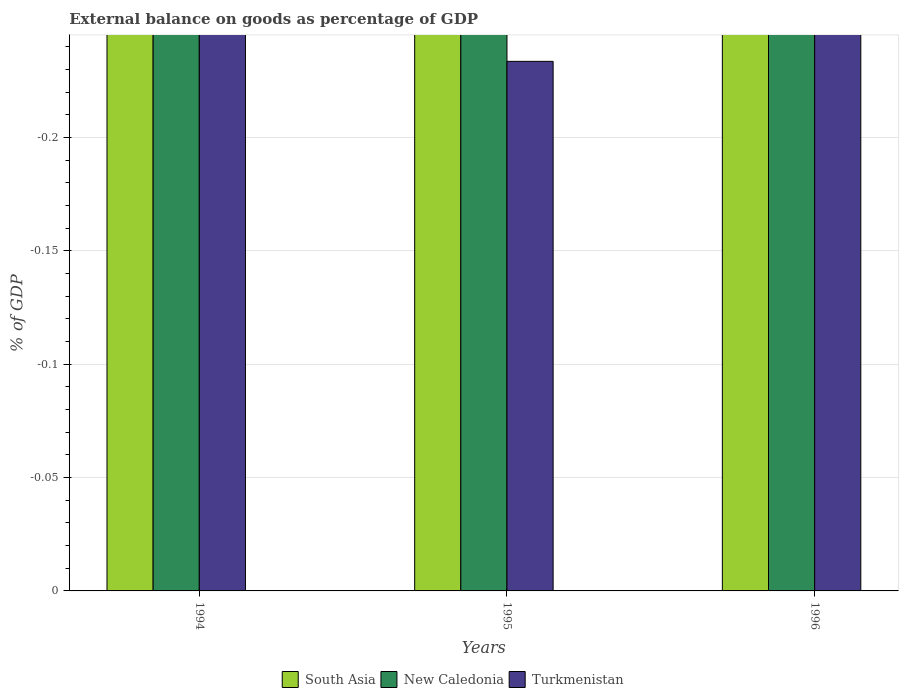How many different coloured bars are there?
Your answer should be compact. 0. Are the number of bars per tick equal to the number of legend labels?
Keep it short and to the point. No. In how many cases, is the number of bars for a given year not equal to the number of legend labels?
Keep it short and to the point. 3. What is the external balance on goods as percentage of GDP in South Asia in 1996?
Offer a terse response. 0. What is the average external balance on goods as percentage of GDP in Turkmenistan per year?
Your answer should be very brief. 0. In how many years, is the external balance on goods as percentage of GDP in South Asia greater than -0.010000000000000002 %?
Provide a succinct answer. 0. Is it the case that in every year, the sum of the external balance on goods as percentage of GDP in New Caledonia and external balance on goods as percentage of GDP in South Asia is greater than the external balance on goods as percentage of GDP in Turkmenistan?
Give a very brief answer. No. Are all the bars in the graph horizontal?
Ensure brevity in your answer.  No. What is the difference between two consecutive major ticks on the Y-axis?
Your answer should be very brief. 0.05. Where does the legend appear in the graph?
Provide a succinct answer. Bottom center. How many legend labels are there?
Your answer should be very brief. 3. How are the legend labels stacked?
Offer a terse response. Horizontal. What is the title of the graph?
Your answer should be compact. External balance on goods as percentage of GDP. What is the label or title of the Y-axis?
Offer a very short reply. % of GDP. What is the % of GDP of New Caledonia in 1994?
Provide a succinct answer. 0. What is the % of GDP of Turkmenistan in 1994?
Make the answer very short. 0. What is the % of GDP in South Asia in 1995?
Make the answer very short. 0. What is the % of GDP of New Caledonia in 1995?
Make the answer very short. 0. What is the % of GDP of South Asia in 1996?
Keep it short and to the point. 0. What is the % of GDP in New Caledonia in 1996?
Keep it short and to the point. 0. What is the % of GDP of Turkmenistan in 1996?
Your answer should be compact. 0. What is the total % of GDP of Turkmenistan in the graph?
Ensure brevity in your answer.  0. What is the average % of GDP of South Asia per year?
Make the answer very short. 0. What is the average % of GDP of New Caledonia per year?
Provide a succinct answer. 0. What is the average % of GDP in Turkmenistan per year?
Ensure brevity in your answer.  0. 